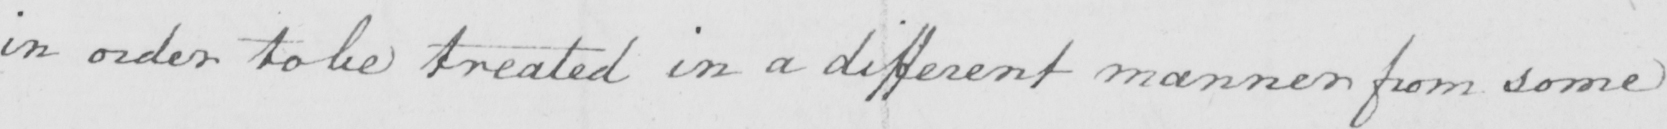Transcribe the text shown in this historical manuscript line. in order to be treated in a different manner from some 